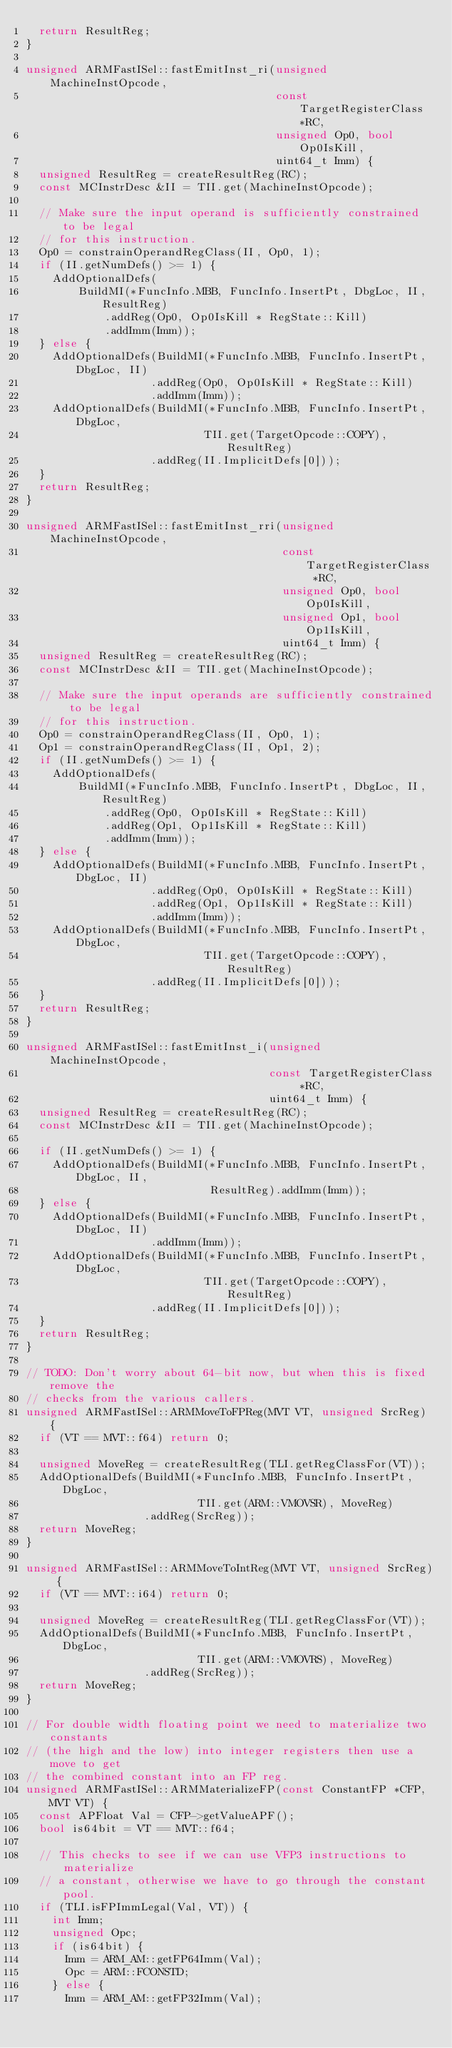Convert code to text. <code><loc_0><loc_0><loc_500><loc_500><_C++_>  return ResultReg;
}

unsigned ARMFastISel::fastEmitInst_ri(unsigned MachineInstOpcode,
                                      const TargetRegisterClass *RC,
                                      unsigned Op0, bool Op0IsKill,
                                      uint64_t Imm) {
  unsigned ResultReg = createResultReg(RC);
  const MCInstrDesc &II = TII.get(MachineInstOpcode);

  // Make sure the input operand is sufficiently constrained to be legal
  // for this instruction.
  Op0 = constrainOperandRegClass(II, Op0, 1);
  if (II.getNumDefs() >= 1) {
    AddOptionalDefs(
        BuildMI(*FuncInfo.MBB, FuncInfo.InsertPt, DbgLoc, II, ResultReg)
            .addReg(Op0, Op0IsKill * RegState::Kill)
            .addImm(Imm));
  } else {
    AddOptionalDefs(BuildMI(*FuncInfo.MBB, FuncInfo.InsertPt, DbgLoc, II)
                   .addReg(Op0, Op0IsKill * RegState::Kill)
                   .addImm(Imm));
    AddOptionalDefs(BuildMI(*FuncInfo.MBB, FuncInfo.InsertPt, DbgLoc,
                           TII.get(TargetOpcode::COPY), ResultReg)
                   .addReg(II.ImplicitDefs[0]));
  }
  return ResultReg;
}

unsigned ARMFastISel::fastEmitInst_rri(unsigned MachineInstOpcode,
                                       const TargetRegisterClass *RC,
                                       unsigned Op0, bool Op0IsKill,
                                       unsigned Op1, bool Op1IsKill,
                                       uint64_t Imm) {
  unsigned ResultReg = createResultReg(RC);
  const MCInstrDesc &II = TII.get(MachineInstOpcode);

  // Make sure the input operands are sufficiently constrained to be legal
  // for this instruction.
  Op0 = constrainOperandRegClass(II, Op0, 1);
  Op1 = constrainOperandRegClass(II, Op1, 2);
  if (II.getNumDefs() >= 1) {
    AddOptionalDefs(
        BuildMI(*FuncInfo.MBB, FuncInfo.InsertPt, DbgLoc, II, ResultReg)
            .addReg(Op0, Op0IsKill * RegState::Kill)
            .addReg(Op1, Op1IsKill * RegState::Kill)
            .addImm(Imm));
  } else {
    AddOptionalDefs(BuildMI(*FuncInfo.MBB, FuncInfo.InsertPt, DbgLoc, II)
                   .addReg(Op0, Op0IsKill * RegState::Kill)
                   .addReg(Op1, Op1IsKill * RegState::Kill)
                   .addImm(Imm));
    AddOptionalDefs(BuildMI(*FuncInfo.MBB, FuncInfo.InsertPt, DbgLoc,
                           TII.get(TargetOpcode::COPY), ResultReg)
                   .addReg(II.ImplicitDefs[0]));
  }
  return ResultReg;
}

unsigned ARMFastISel::fastEmitInst_i(unsigned MachineInstOpcode,
                                     const TargetRegisterClass *RC,
                                     uint64_t Imm) {
  unsigned ResultReg = createResultReg(RC);
  const MCInstrDesc &II = TII.get(MachineInstOpcode);

  if (II.getNumDefs() >= 1) {
    AddOptionalDefs(BuildMI(*FuncInfo.MBB, FuncInfo.InsertPt, DbgLoc, II,
                            ResultReg).addImm(Imm));
  } else {
    AddOptionalDefs(BuildMI(*FuncInfo.MBB, FuncInfo.InsertPt, DbgLoc, II)
                   .addImm(Imm));
    AddOptionalDefs(BuildMI(*FuncInfo.MBB, FuncInfo.InsertPt, DbgLoc,
                           TII.get(TargetOpcode::COPY), ResultReg)
                   .addReg(II.ImplicitDefs[0]));
  }
  return ResultReg;
}

// TODO: Don't worry about 64-bit now, but when this is fixed remove the
// checks from the various callers.
unsigned ARMFastISel::ARMMoveToFPReg(MVT VT, unsigned SrcReg) {
  if (VT == MVT::f64) return 0;

  unsigned MoveReg = createResultReg(TLI.getRegClassFor(VT));
  AddOptionalDefs(BuildMI(*FuncInfo.MBB, FuncInfo.InsertPt, DbgLoc,
                          TII.get(ARM::VMOVSR), MoveReg)
                  .addReg(SrcReg));
  return MoveReg;
}

unsigned ARMFastISel::ARMMoveToIntReg(MVT VT, unsigned SrcReg) {
  if (VT == MVT::i64) return 0;

  unsigned MoveReg = createResultReg(TLI.getRegClassFor(VT));
  AddOptionalDefs(BuildMI(*FuncInfo.MBB, FuncInfo.InsertPt, DbgLoc,
                          TII.get(ARM::VMOVRS), MoveReg)
                  .addReg(SrcReg));
  return MoveReg;
}

// For double width floating point we need to materialize two constants
// (the high and the low) into integer registers then use a move to get
// the combined constant into an FP reg.
unsigned ARMFastISel::ARMMaterializeFP(const ConstantFP *CFP, MVT VT) {
  const APFloat Val = CFP->getValueAPF();
  bool is64bit = VT == MVT::f64;

  // This checks to see if we can use VFP3 instructions to materialize
  // a constant, otherwise we have to go through the constant pool.
  if (TLI.isFPImmLegal(Val, VT)) {
    int Imm;
    unsigned Opc;
    if (is64bit) {
      Imm = ARM_AM::getFP64Imm(Val);
      Opc = ARM::FCONSTD;
    } else {
      Imm = ARM_AM::getFP32Imm(Val);</code> 